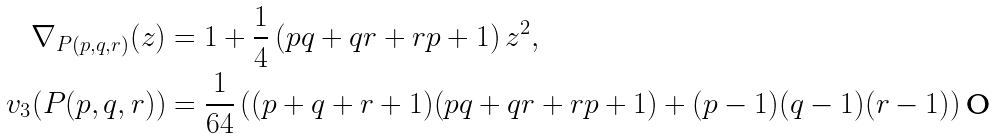<formula> <loc_0><loc_0><loc_500><loc_500>\nabla _ { P ( p , q , r ) } ( z ) & = 1 + \frac { 1 } { 4 } \left ( p q + q r + r p + 1 \right ) z ^ { 2 } , \\ v _ { 3 } ( P ( p , q , r ) ) & = \frac { 1 } { 6 4 } \left ( ( p + q + r + 1 ) ( p q + q r + r p + 1 ) + ( p - 1 ) ( q - 1 ) ( r - 1 ) \right )</formula> 